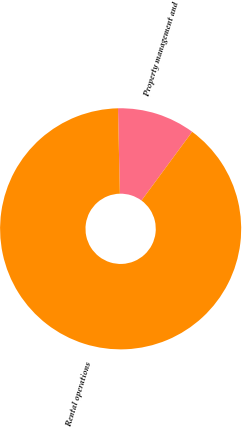Convert chart. <chart><loc_0><loc_0><loc_500><loc_500><pie_chart><fcel>Property management and<fcel>Rental operations<nl><fcel>10.46%<fcel>89.54%<nl></chart> 